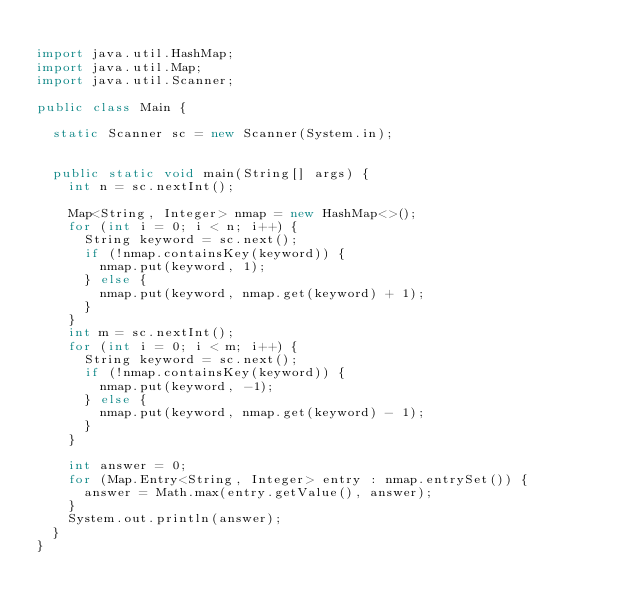Convert code to text. <code><loc_0><loc_0><loc_500><loc_500><_Java_>
import java.util.HashMap;
import java.util.Map;
import java.util.Scanner;

public class Main {

  static Scanner sc = new Scanner(System.in);


  public static void main(String[] args) {
    int n = sc.nextInt();

    Map<String, Integer> nmap = new HashMap<>();
    for (int i = 0; i < n; i++) {
      String keyword = sc.next();
      if (!nmap.containsKey(keyword)) {
        nmap.put(keyword, 1);
      } else {
        nmap.put(keyword, nmap.get(keyword) + 1);
      }
    }
    int m = sc.nextInt();
    for (int i = 0; i < m; i++) {
      String keyword = sc.next();
      if (!nmap.containsKey(keyword)) {
        nmap.put(keyword, -1);
      } else {
        nmap.put(keyword, nmap.get(keyword) - 1);
      }
    }

    int answer = 0;
    for (Map.Entry<String, Integer> entry : nmap.entrySet()) {
      answer = Math.max(entry.getValue(), answer);
    }
    System.out.println(answer);
  }
}
</code> 